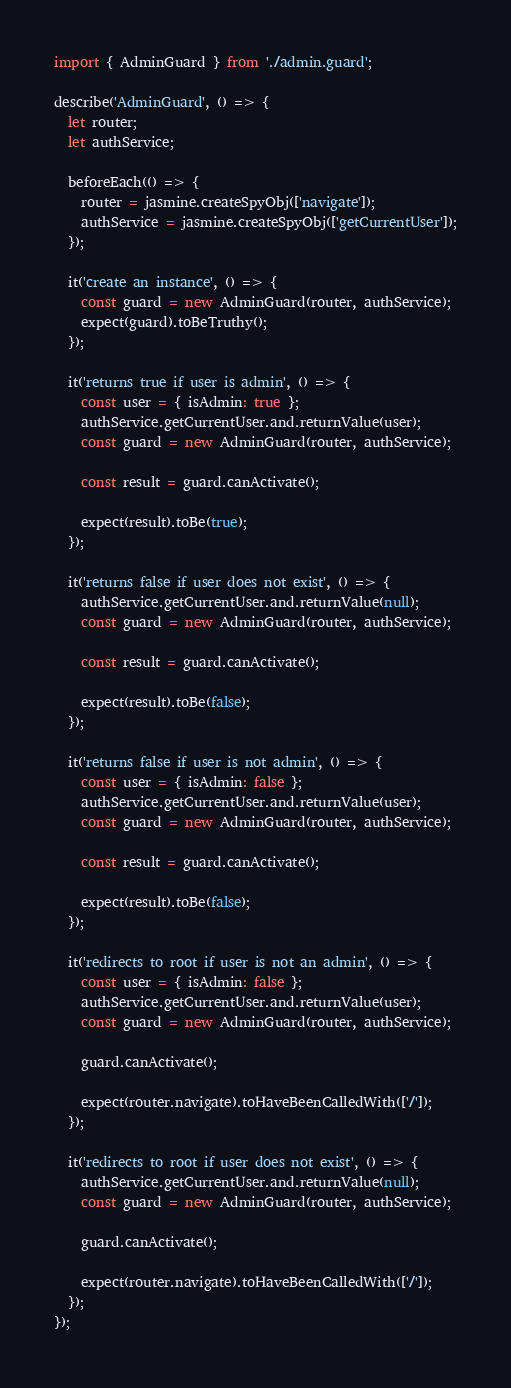<code> <loc_0><loc_0><loc_500><loc_500><_TypeScript_>import { AdminGuard } from './admin.guard';

describe('AdminGuard', () => {
  let router;
  let authService;

  beforeEach(() => {
    router = jasmine.createSpyObj(['navigate']);
    authService = jasmine.createSpyObj(['getCurrentUser']);
  });

  it('create an instance', () => {
    const guard = new AdminGuard(router, authService);
    expect(guard).toBeTruthy();
  });

  it('returns true if user is admin', () => {
    const user = { isAdmin: true };
    authService.getCurrentUser.and.returnValue(user);
    const guard = new AdminGuard(router, authService);

    const result = guard.canActivate();

    expect(result).toBe(true);
  });

  it('returns false if user does not exist', () => {
    authService.getCurrentUser.and.returnValue(null);
    const guard = new AdminGuard(router, authService);

    const result = guard.canActivate();

    expect(result).toBe(false);
  });

  it('returns false if user is not admin', () => {
    const user = { isAdmin: false };
    authService.getCurrentUser.and.returnValue(user);
    const guard = new AdminGuard(router, authService);

    const result = guard.canActivate();

    expect(result).toBe(false);
  });

  it('redirects to root if user is not an admin', () => {
    const user = { isAdmin: false };
    authService.getCurrentUser.and.returnValue(user);
    const guard = new AdminGuard(router, authService);

    guard.canActivate();

    expect(router.navigate).toHaveBeenCalledWith(['/']);
  });

  it('redirects to root if user does not exist', () => {
    authService.getCurrentUser.and.returnValue(null);
    const guard = new AdminGuard(router, authService);

    guard.canActivate();

    expect(router.navigate).toHaveBeenCalledWith(['/']);
  });
});
</code> 